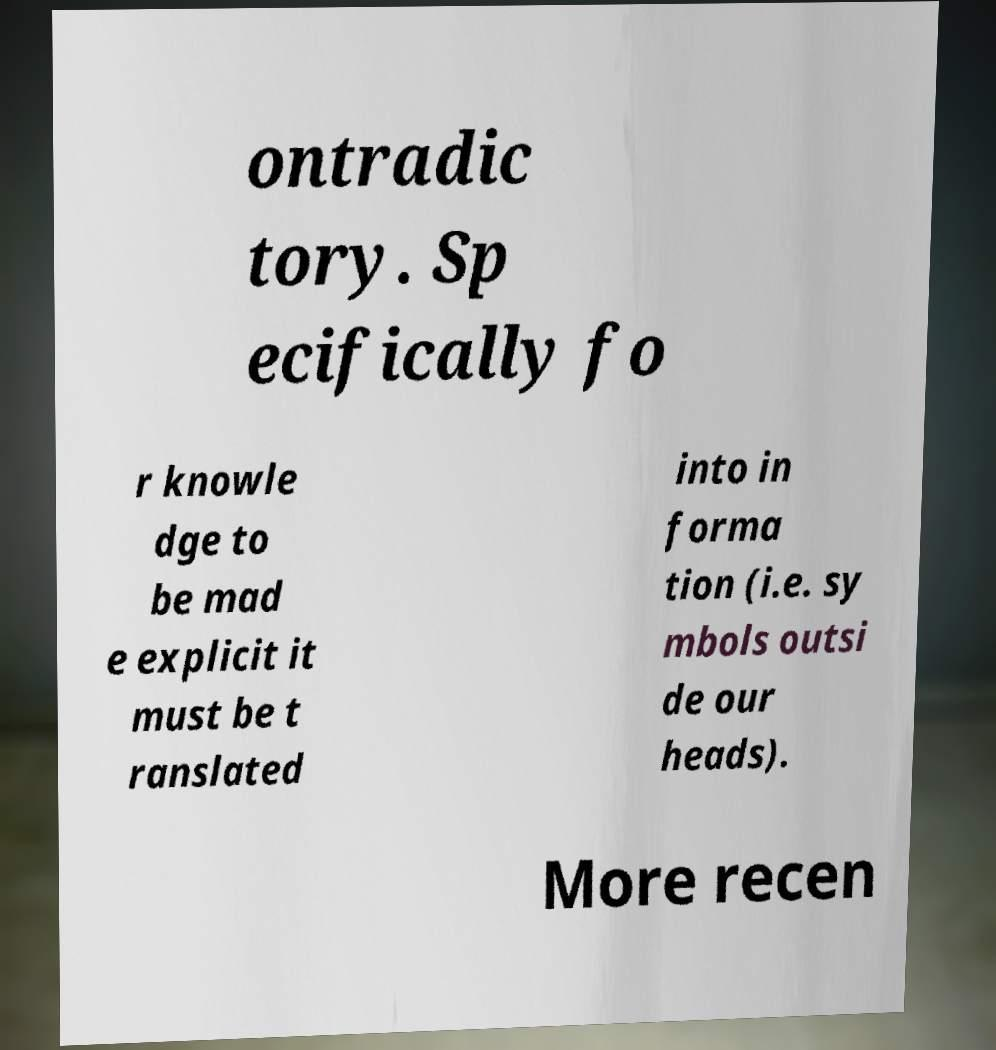For documentation purposes, I need the text within this image transcribed. Could you provide that? ontradic tory. Sp ecifically fo r knowle dge to be mad e explicit it must be t ranslated into in forma tion (i.e. sy mbols outsi de our heads). More recen 